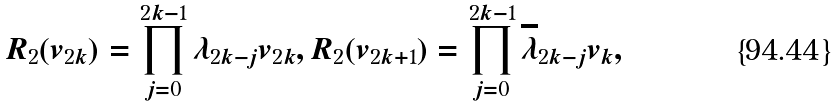Convert formula to latex. <formula><loc_0><loc_0><loc_500><loc_500>R _ { 2 } ( v _ { 2 k } ) = \prod _ { j = 0 } ^ { 2 k - 1 } { \lambda } _ { 2 k - j } v _ { 2 k } , R _ { 2 } ( v _ { 2 k + 1 } ) = \prod _ { j = 0 } ^ { 2 k - 1 } { \overline { \lambda } } _ { 2 k - j } v _ { k } ,</formula> 